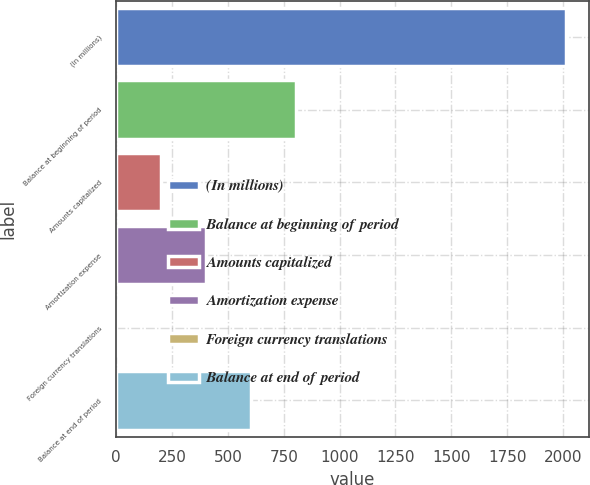<chart> <loc_0><loc_0><loc_500><loc_500><bar_chart><fcel>(In millions)<fcel>Balance at beginning of period<fcel>Amounts capitalized<fcel>Amortization expense<fcel>Foreign currency translations<fcel>Balance at end of period<nl><fcel>2014<fcel>806.2<fcel>202.3<fcel>403.6<fcel>1<fcel>604.9<nl></chart> 